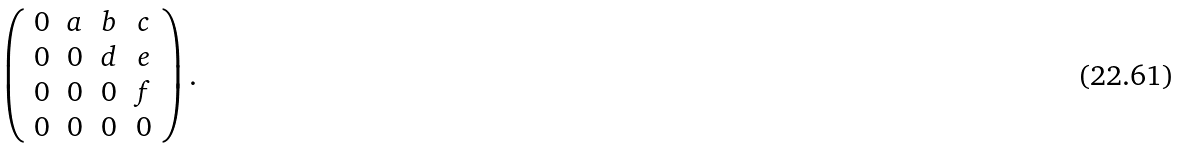<formula> <loc_0><loc_0><loc_500><loc_500>\left ( \begin{array} { c c c c } 0 & a & b & c \\ 0 & 0 & d & e \\ 0 & 0 & 0 & f \\ 0 & 0 & 0 & 0 \end{array} \right ) .</formula> 